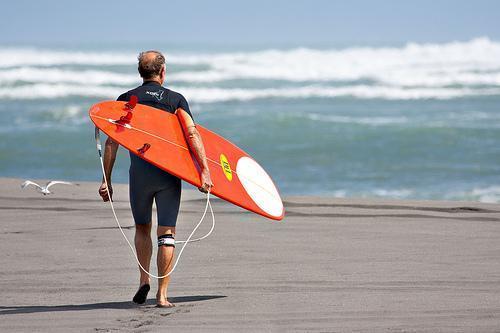How many birds on the shore?
Give a very brief answer. 1. 